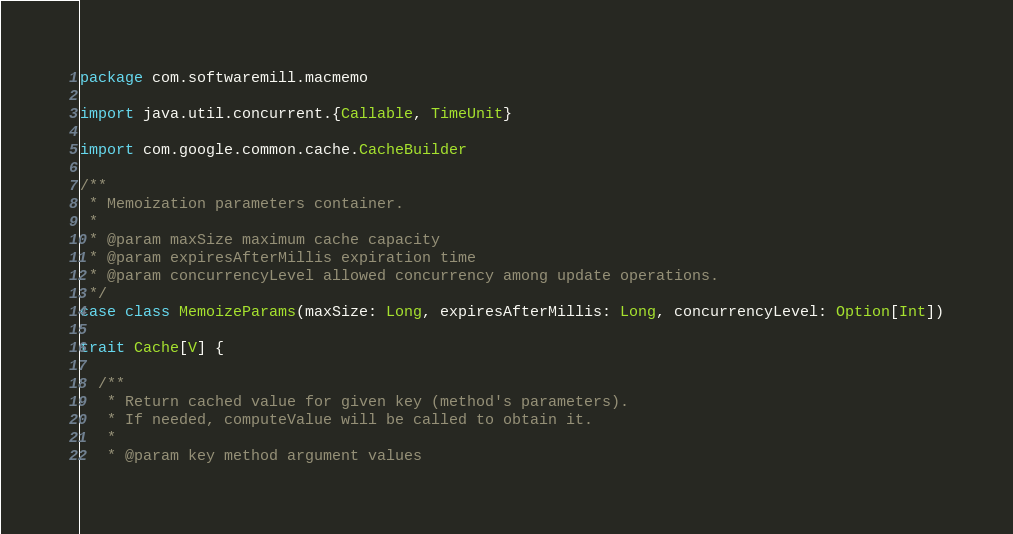Convert code to text. <code><loc_0><loc_0><loc_500><loc_500><_Scala_>package com.softwaremill.macmemo

import java.util.concurrent.{Callable, TimeUnit}

import com.google.common.cache.CacheBuilder

/**
 * Memoization parameters container.
 *
 * @param maxSize maximum cache capacity
 * @param expiresAfterMillis expiration time
 * @param concurrencyLevel allowed concurrency among update operations.
 */
case class MemoizeParams(maxSize: Long, expiresAfterMillis: Long, concurrencyLevel: Option[Int])

trait Cache[V] {

  /**
   * Return cached value for given key (method's parameters).
   * If needed, computeValue will be called to obtain it.
   *
   * @param key method argument values</code> 